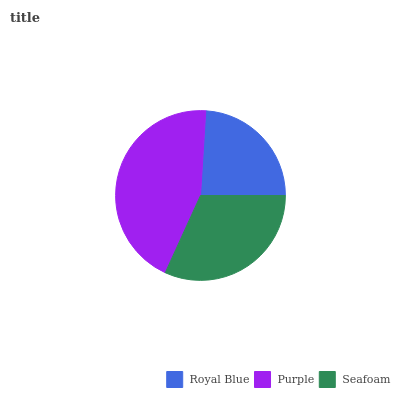Is Royal Blue the minimum?
Answer yes or no. Yes. Is Purple the maximum?
Answer yes or no. Yes. Is Seafoam the minimum?
Answer yes or no. No. Is Seafoam the maximum?
Answer yes or no. No. Is Purple greater than Seafoam?
Answer yes or no. Yes. Is Seafoam less than Purple?
Answer yes or no. Yes. Is Seafoam greater than Purple?
Answer yes or no. No. Is Purple less than Seafoam?
Answer yes or no. No. Is Seafoam the high median?
Answer yes or no. Yes. Is Seafoam the low median?
Answer yes or no. Yes. Is Purple the high median?
Answer yes or no. No. Is Royal Blue the low median?
Answer yes or no. No. 